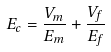<formula> <loc_0><loc_0><loc_500><loc_500>E _ { c } = \frac { V _ { m } } { E _ { m } } + \frac { V _ { f } } { E _ { f } }</formula> 